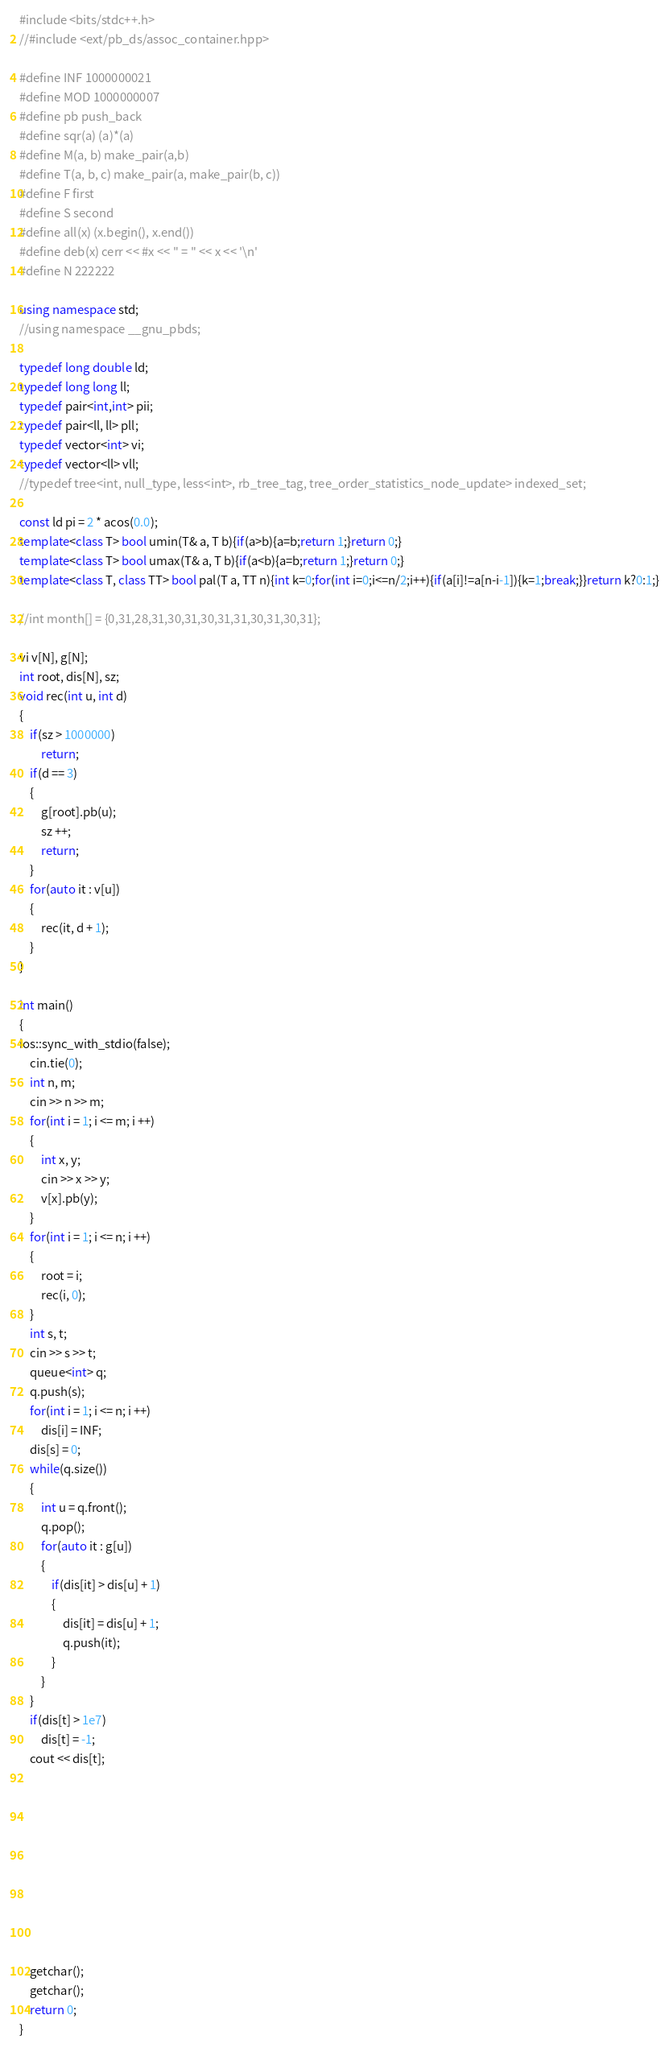<code> <loc_0><loc_0><loc_500><loc_500><_C++_>#include <bits/stdc++.h>
//#include <ext/pb_ds/assoc_container.hpp>

#define INF 1000000021
#define MOD 1000000007
#define pb push_back
#define sqr(a) (a)*(a)
#define M(a, b) make_pair(a,b)
#define T(a, b, c) make_pair(a, make_pair(b, c))
#define F first
#define S second
#define all(x) (x.begin(), x.end())
#define deb(x) cerr << #x << " = " << x << '\n'
#define N 222222

using namespace std;
//using namespace __gnu_pbds;

typedef long double ld;
typedef long long ll;
typedef pair<int,int> pii;
typedef pair<ll, ll> pll;
typedef vector<int> vi;
typedef vector<ll> vll;
//typedef tree<int, null_type, less<int>, rb_tree_tag, tree_order_statistics_node_update> indexed_set;

const ld pi = 2 * acos(0.0);
template<class T> bool umin(T& a, T b){if(a>b){a=b;return 1;}return 0;}
template<class T> bool umax(T& a, T b){if(a<b){a=b;return 1;}return 0;}
template<class T, class TT> bool pal(T a, TT n){int k=0;for(int i=0;i<=n/2;i++){if(a[i]!=a[n-i-1]){k=1;break;}}return k?0:1;}

//int month[] = {0,31,28,31,30,31,30,31,31,30,31,30,31};

vi v[N], g[N];
int root, dis[N], sz;
void rec(int u, int d)
{
	if(sz > 1000000)
		return;
	if(d == 3)
	{
		g[root].pb(u);
		sz ++;
		return;
	}
	for(auto it : v[u])
	{
		rec(it, d + 1);
	}
}

int main()
{
ios::sync_with_stdio(false);
	cin.tie(0);
	int n, m;
	cin >> n >> m;
	for(int i = 1; i <= m; i ++)
	{
		int x, y;
		cin >> x >> y;
		v[x].pb(y);
	}
	for(int i = 1; i <= n; i ++)
	{
		root = i;
		rec(i, 0);
	}
	int s, t;
	cin >> s >> t;
	queue<int> q;
	q.push(s);
	for(int i = 1; i <= n; i ++)
		dis[i] = INF;
	dis[s] = 0;
	while(q.size())
	{
		int u = q.front();
		q.pop();
		for(auto it : g[u])
		{
			if(dis[it] > dis[u] + 1)
			{
				dis[it] = dis[u] + 1;
				q.push(it);
			}
		}
	}
	if(dis[t] > 1e7)
		dis[t] = -1;
	cout << dis[t];




	





	getchar();
	getchar();
	return 0;
}</code> 